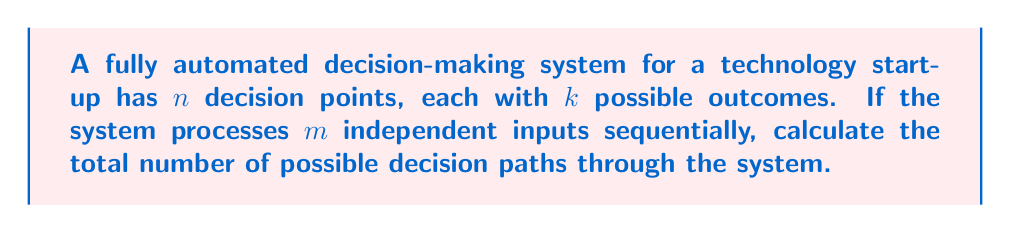Help me with this question. Let's approach this step-by-step:

1) For each input, the system goes through $n$ decision points.

2) At each decision point, there are $k$ possible outcomes.

3) For a single input, the number of possible paths is:
   $$k^n$$
   This is because we're making $n$ independent choices, each with $k$ options.

4) Now, we process $m$ inputs sequentially. This means we're repeating this process $m$ times.

5) For each subsequent input, we have the same number of possibilities, regardless of the choices made for previous inputs.

6) Therefore, we can apply the multiplication principle. The total number of possible decision paths is:
   $$(k^n)^m = k^{nm}$$

This represents the total number of ways the automated system could process $m$ inputs through $n$ decision points with $k$ options each.
Answer: $$k^{nm}$$ 